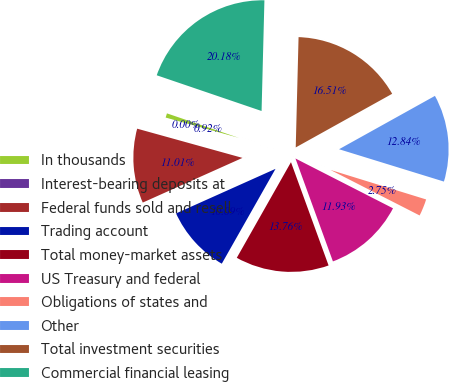<chart> <loc_0><loc_0><loc_500><loc_500><pie_chart><fcel>In thousands<fcel>Interest-bearing deposits at<fcel>Federal funds sold and resell<fcel>Trading account<fcel>Total money-market assets<fcel>US Treasury and federal<fcel>Obligations of states and<fcel>Other<fcel>Total investment securities<fcel>Commercial financial leasing<nl><fcel>0.92%<fcel>0.0%<fcel>11.01%<fcel>10.09%<fcel>13.76%<fcel>11.93%<fcel>2.75%<fcel>12.84%<fcel>16.51%<fcel>20.18%<nl></chart> 